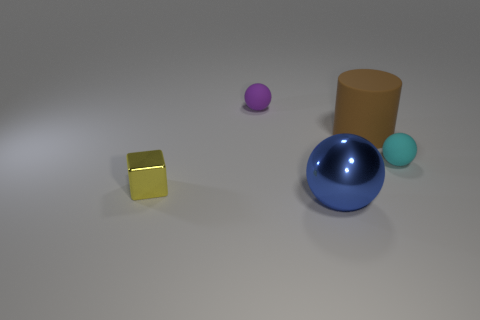Can you describe the lighting and shadows in the scene? The lighting in the scene is diffuse, generally coming from above. Shadows are soft and extend primarily to the right of the objects, suggesting a light source from the upper left. The objects have subtle highlights, particularly noticeable on the glossy surfaces of the balls and the cube. How does the lighting affect the appearance of the materials? The lighting accentuates the reflective qualities of the shiny materials, giving the blue ball and yellow cube a more three-dimensional appearance with specular highlights. The matte surface of the brown cylinder and the smaller blue ball, however, reflects less light, showcasing their less reflective, flat texture. 